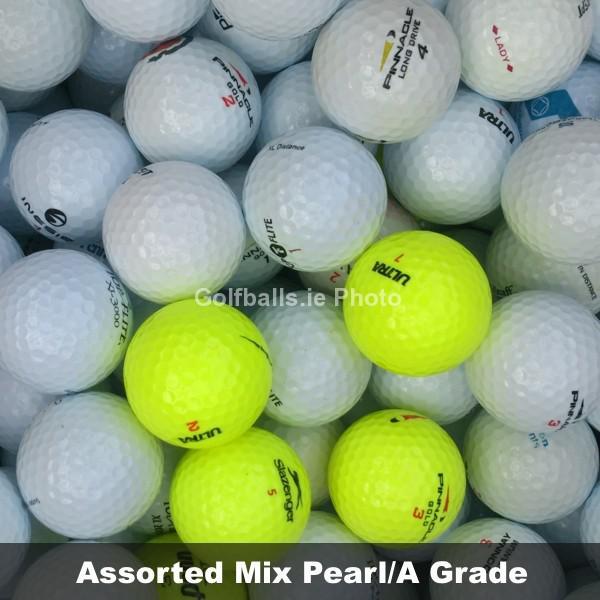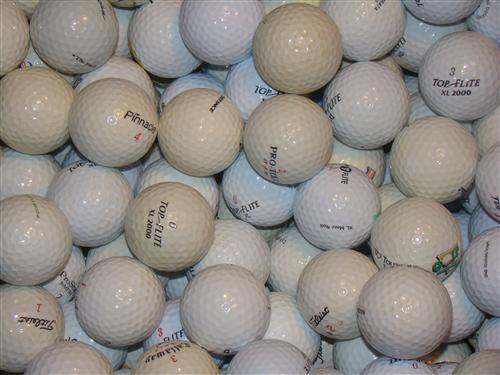The first image is the image on the left, the second image is the image on the right. For the images shown, is this caption "Right and left images show only clean-looking white balls." true? Answer yes or no. No. 